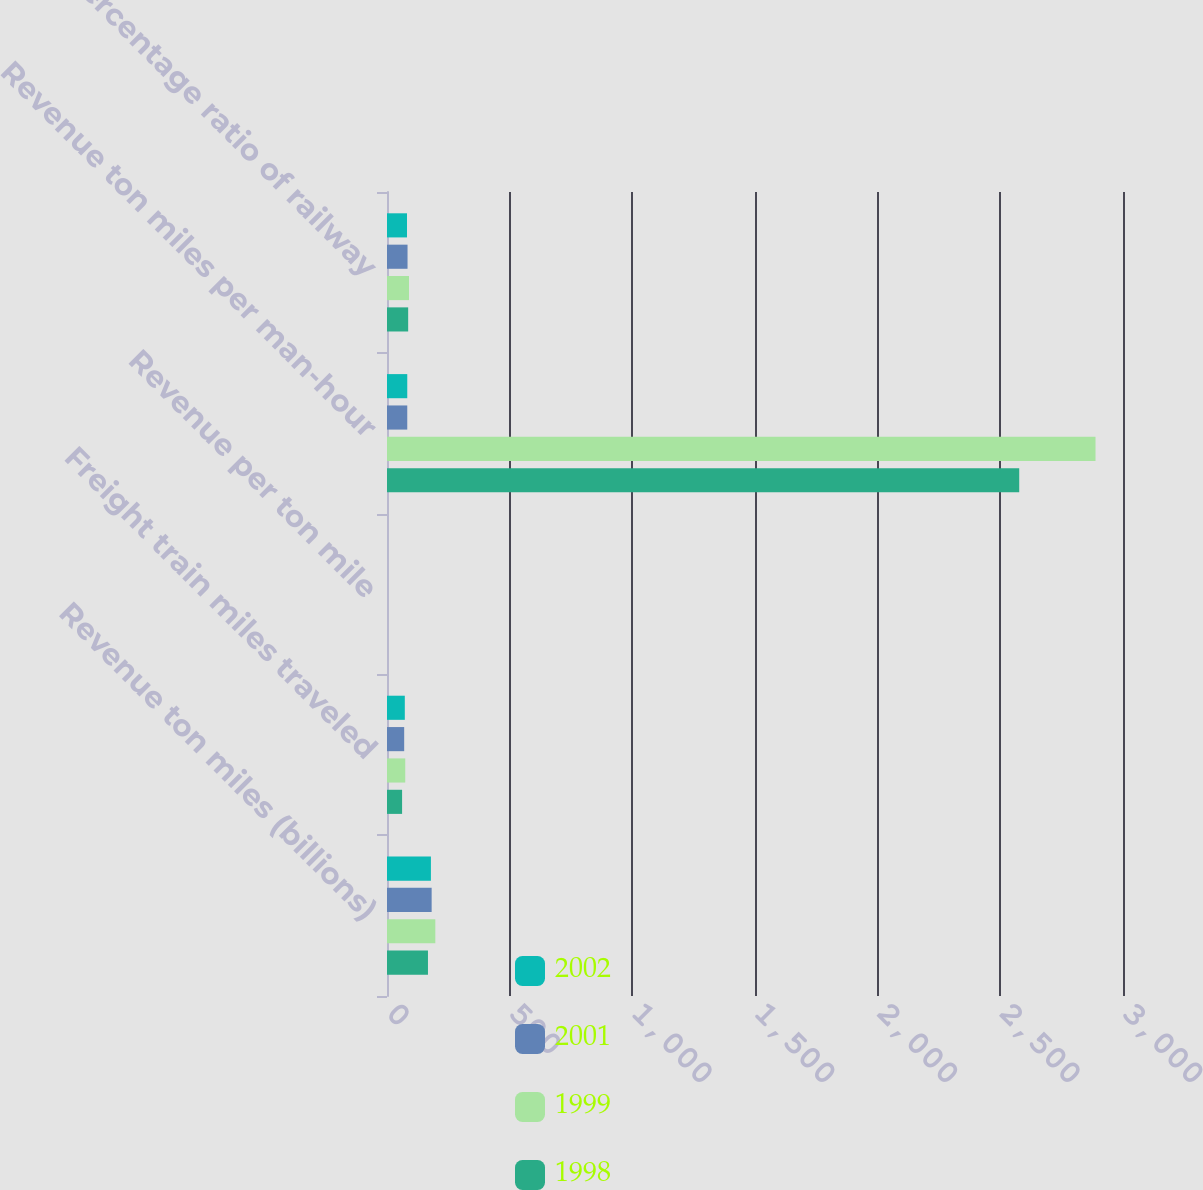<chart> <loc_0><loc_0><loc_500><loc_500><stacked_bar_chart><ecel><fcel>Revenue ton miles (billions)<fcel>Freight train miles traveled<fcel>Revenue per ton mile<fcel>Revenue ton miles per man-hour<fcel>Percentage ratio of railway<nl><fcel>2002<fcel>179<fcel>72.6<fcel>0.04<fcel>82.6<fcel>81.5<nl><fcel>2001<fcel>182<fcel>70<fcel>0.03<fcel>82.6<fcel>83.7<nl><fcel>1999<fcel>197<fcel>74.4<fcel>0.03<fcel>2888<fcel>89.7<nl><fcel>1998<fcel>167<fcel>61.5<fcel>0.03<fcel>2577<fcel>86.3<nl></chart> 